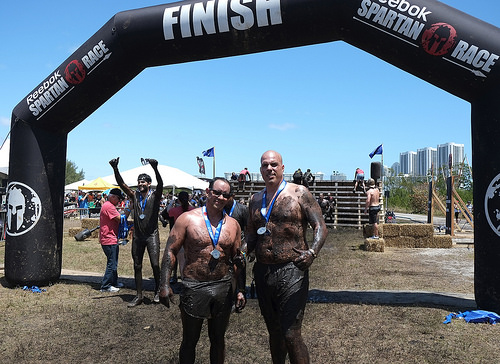<image>
Can you confirm if the racer is to the left of the racer? Yes. From this viewpoint, the racer is positioned to the left side relative to the racer. 